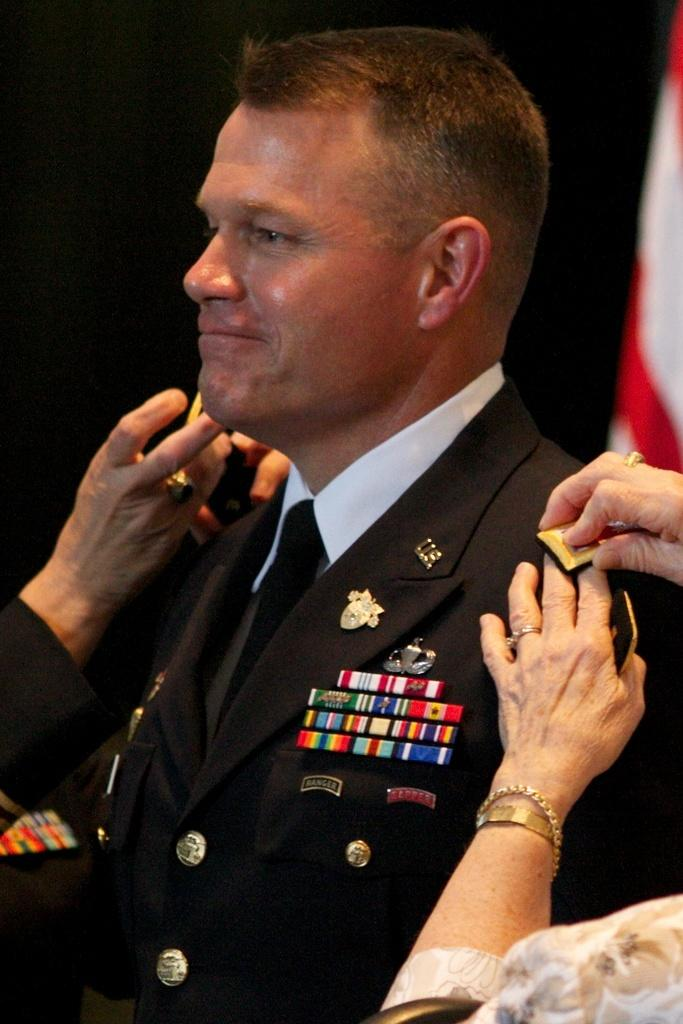Who is the main subject in the image? There is a man in the center of the image. What is the man doing in the image? The man is smiling. Are there any other people in the image? Yes, there are other persons in the image. What are the other persons doing to the man in the center? The other persons are putting badges on the man in the center. What can be seen in the background of the image? There is a flag in the background of the image. How many pigs are visible in the image? There are no pigs present in the image. What type of club is the man holding in the image? There is no club visible in the image. 